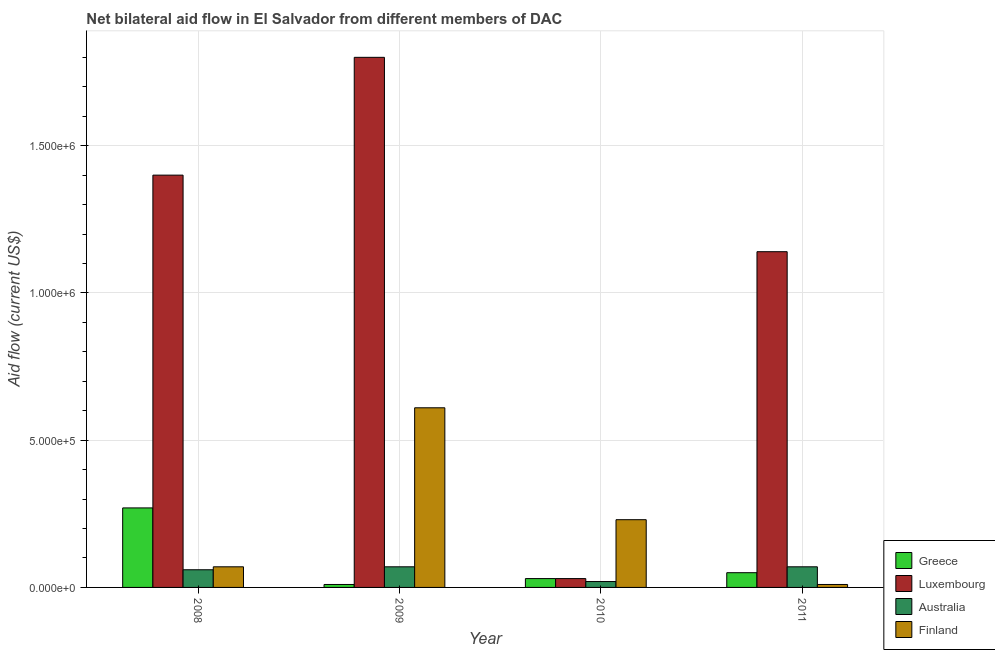How many groups of bars are there?
Your answer should be compact. 4. How many bars are there on the 4th tick from the right?
Keep it short and to the point. 4. What is the amount of aid given by australia in 2009?
Your answer should be compact. 7.00e+04. Across all years, what is the maximum amount of aid given by finland?
Keep it short and to the point. 6.10e+05. Across all years, what is the minimum amount of aid given by finland?
Make the answer very short. 10000. In which year was the amount of aid given by finland maximum?
Your answer should be compact. 2009. What is the total amount of aid given by finland in the graph?
Keep it short and to the point. 9.20e+05. What is the difference between the amount of aid given by greece in 2008 and that in 2011?
Make the answer very short. 2.20e+05. What is the difference between the amount of aid given by greece in 2010 and the amount of aid given by australia in 2011?
Give a very brief answer. -2.00e+04. What is the average amount of aid given by finland per year?
Your answer should be very brief. 2.30e+05. In how many years, is the amount of aid given by greece greater than 600000 US$?
Make the answer very short. 0. What is the ratio of the amount of aid given by luxembourg in 2008 to that in 2010?
Your answer should be compact. 46.67. Is the difference between the amount of aid given by australia in 2008 and 2010 greater than the difference between the amount of aid given by luxembourg in 2008 and 2010?
Ensure brevity in your answer.  No. What is the difference between the highest and the second highest amount of aid given by luxembourg?
Keep it short and to the point. 4.00e+05. What is the difference between the highest and the lowest amount of aid given by australia?
Offer a very short reply. 5.00e+04. Is it the case that in every year, the sum of the amount of aid given by greece and amount of aid given by luxembourg is greater than the amount of aid given by australia?
Provide a short and direct response. Yes. How many bars are there?
Offer a very short reply. 16. Are the values on the major ticks of Y-axis written in scientific E-notation?
Offer a very short reply. Yes. Does the graph contain any zero values?
Offer a terse response. No. Does the graph contain grids?
Provide a succinct answer. Yes. What is the title of the graph?
Make the answer very short. Net bilateral aid flow in El Salvador from different members of DAC. Does "Portugal" appear as one of the legend labels in the graph?
Your response must be concise. No. What is the label or title of the Y-axis?
Provide a succinct answer. Aid flow (current US$). What is the Aid flow (current US$) of Luxembourg in 2008?
Give a very brief answer. 1.40e+06. What is the Aid flow (current US$) in Australia in 2008?
Your answer should be very brief. 6.00e+04. What is the Aid flow (current US$) of Finland in 2008?
Provide a succinct answer. 7.00e+04. What is the Aid flow (current US$) in Greece in 2009?
Provide a short and direct response. 10000. What is the Aid flow (current US$) in Luxembourg in 2009?
Provide a short and direct response. 1.80e+06. What is the Aid flow (current US$) of Luxembourg in 2010?
Your answer should be compact. 3.00e+04. What is the Aid flow (current US$) of Greece in 2011?
Ensure brevity in your answer.  5.00e+04. What is the Aid flow (current US$) in Luxembourg in 2011?
Make the answer very short. 1.14e+06. What is the Aid flow (current US$) in Australia in 2011?
Your response must be concise. 7.00e+04. Across all years, what is the maximum Aid flow (current US$) of Greece?
Offer a terse response. 2.70e+05. Across all years, what is the maximum Aid flow (current US$) in Luxembourg?
Ensure brevity in your answer.  1.80e+06. Across all years, what is the minimum Aid flow (current US$) in Greece?
Your answer should be very brief. 10000. Across all years, what is the minimum Aid flow (current US$) of Australia?
Provide a short and direct response. 2.00e+04. What is the total Aid flow (current US$) of Luxembourg in the graph?
Your answer should be very brief. 4.37e+06. What is the total Aid flow (current US$) of Finland in the graph?
Provide a short and direct response. 9.20e+05. What is the difference between the Aid flow (current US$) in Luxembourg in 2008 and that in 2009?
Provide a succinct answer. -4.00e+05. What is the difference between the Aid flow (current US$) of Finland in 2008 and that in 2009?
Your response must be concise. -5.40e+05. What is the difference between the Aid flow (current US$) of Greece in 2008 and that in 2010?
Your answer should be very brief. 2.40e+05. What is the difference between the Aid flow (current US$) of Luxembourg in 2008 and that in 2010?
Keep it short and to the point. 1.37e+06. What is the difference between the Aid flow (current US$) of Luxembourg in 2008 and that in 2011?
Your answer should be compact. 2.60e+05. What is the difference between the Aid flow (current US$) of Luxembourg in 2009 and that in 2010?
Make the answer very short. 1.77e+06. What is the difference between the Aid flow (current US$) in Luxembourg in 2009 and that in 2011?
Your answer should be very brief. 6.60e+05. What is the difference between the Aid flow (current US$) in Luxembourg in 2010 and that in 2011?
Give a very brief answer. -1.11e+06. What is the difference between the Aid flow (current US$) of Australia in 2010 and that in 2011?
Provide a succinct answer. -5.00e+04. What is the difference between the Aid flow (current US$) of Finland in 2010 and that in 2011?
Offer a terse response. 2.20e+05. What is the difference between the Aid flow (current US$) in Greece in 2008 and the Aid flow (current US$) in Luxembourg in 2009?
Provide a succinct answer. -1.53e+06. What is the difference between the Aid flow (current US$) in Greece in 2008 and the Aid flow (current US$) in Australia in 2009?
Ensure brevity in your answer.  2.00e+05. What is the difference between the Aid flow (current US$) of Greece in 2008 and the Aid flow (current US$) of Finland in 2009?
Keep it short and to the point. -3.40e+05. What is the difference between the Aid flow (current US$) in Luxembourg in 2008 and the Aid flow (current US$) in Australia in 2009?
Provide a short and direct response. 1.33e+06. What is the difference between the Aid flow (current US$) of Luxembourg in 2008 and the Aid flow (current US$) of Finland in 2009?
Ensure brevity in your answer.  7.90e+05. What is the difference between the Aid flow (current US$) of Australia in 2008 and the Aid flow (current US$) of Finland in 2009?
Provide a succinct answer. -5.50e+05. What is the difference between the Aid flow (current US$) of Greece in 2008 and the Aid flow (current US$) of Luxembourg in 2010?
Keep it short and to the point. 2.40e+05. What is the difference between the Aid flow (current US$) in Greece in 2008 and the Aid flow (current US$) in Australia in 2010?
Provide a short and direct response. 2.50e+05. What is the difference between the Aid flow (current US$) of Greece in 2008 and the Aid flow (current US$) of Finland in 2010?
Provide a succinct answer. 4.00e+04. What is the difference between the Aid flow (current US$) in Luxembourg in 2008 and the Aid flow (current US$) in Australia in 2010?
Give a very brief answer. 1.38e+06. What is the difference between the Aid flow (current US$) of Luxembourg in 2008 and the Aid flow (current US$) of Finland in 2010?
Offer a very short reply. 1.17e+06. What is the difference between the Aid flow (current US$) of Australia in 2008 and the Aid flow (current US$) of Finland in 2010?
Your response must be concise. -1.70e+05. What is the difference between the Aid flow (current US$) in Greece in 2008 and the Aid flow (current US$) in Luxembourg in 2011?
Make the answer very short. -8.70e+05. What is the difference between the Aid flow (current US$) in Greece in 2008 and the Aid flow (current US$) in Australia in 2011?
Offer a terse response. 2.00e+05. What is the difference between the Aid flow (current US$) of Luxembourg in 2008 and the Aid flow (current US$) of Australia in 2011?
Your response must be concise. 1.33e+06. What is the difference between the Aid flow (current US$) of Luxembourg in 2008 and the Aid flow (current US$) of Finland in 2011?
Offer a terse response. 1.39e+06. What is the difference between the Aid flow (current US$) of Greece in 2009 and the Aid flow (current US$) of Finland in 2010?
Your answer should be very brief. -2.20e+05. What is the difference between the Aid flow (current US$) of Luxembourg in 2009 and the Aid flow (current US$) of Australia in 2010?
Provide a short and direct response. 1.78e+06. What is the difference between the Aid flow (current US$) in Luxembourg in 2009 and the Aid flow (current US$) in Finland in 2010?
Keep it short and to the point. 1.57e+06. What is the difference between the Aid flow (current US$) in Australia in 2009 and the Aid flow (current US$) in Finland in 2010?
Your answer should be compact. -1.60e+05. What is the difference between the Aid flow (current US$) of Greece in 2009 and the Aid flow (current US$) of Luxembourg in 2011?
Your answer should be very brief. -1.13e+06. What is the difference between the Aid flow (current US$) in Greece in 2009 and the Aid flow (current US$) in Australia in 2011?
Ensure brevity in your answer.  -6.00e+04. What is the difference between the Aid flow (current US$) in Luxembourg in 2009 and the Aid flow (current US$) in Australia in 2011?
Provide a succinct answer. 1.73e+06. What is the difference between the Aid flow (current US$) in Luxembourg in 2009 and the Aid flow (current US$) in Finland in 2011?
Keep it short and to the point. 1.79e+06. What is the difference between the Aid flow (current US$) in Greece in 2010 and the Aid flow (current US$) in Luxembourg in 2011?
Your response must be concise. -1.11e+06. What is the difference between the Aid flow (current US$) in Greece in 2010 and the Aid flow (current US$) in Australia in 2011?
Make the answer very short. -4.00e+04. What is the difference between the Aid flow (current US$) of Luxembourg in 2010 and the Aid flow (current US$) of Australia in 2011?
Your answer should be very brief. -4.00e+04. What is the difference between the Aid flow (current US$) of Australia in 2010 and the Aid flow (current US$) of Finland in 2011?
Your answer should be compact. 10000. What is the average Aid flow (current US$) in Luxembourg per year?
Offer a terse response. 1.09e+06. What is the average Aid flow (current US$) in Australia per year?
Your answer should be compact. 5.50e+04. What is the average Aid flow (current US$) in Finland per year?
Your answer should be compact. 2.30e+05. In the year 2008, what is the difference between the Aid flow (current US$) of Greece and Aid flow (current US$) of Luxembourg?
Offer a terse response. -1.13e+06. In the year 2008, what is the difference between the Aid flow (current US$) of Greece and Aid flow (current US$) of Australia?
Your answer should be compact. 2.10e+05. In the year 2008, what is the difference between the Aid flow (current US$) of Luxembourg and Aid flow (current US$) of Australia?
Provide a short and direct response. 1.34e+06. In the year 2008, what is the difference between the Aid flow (current US$) in Luxembourg and Aid flow (current US$) in Finland?
Ensure brevity in your answer.  1.33e+06. In the year 2009, what is the difference between the Aid flow (current US$) in Greece and Aid flow (current US$) in Luxembourg?
Provide a succinct answer. -1.79e+06. In the year 2009, what is the difference between the Aid flow (current US$) of Greece and Aid flow (current US$) of Finland?
Your answer should be very brief. -6.00e+05. In the year 2009, what is the difference between the Aid flow (current US$) in Luxembourg and Aid flow (current US$) in Australia?
Offer a very short reply. 1.73e+06. In the year 2009, what is the difference between the Aid flow (current US$) in Luxembourg and Aid flow (current US$) in Finland?
Offer a very short reply. 1.19e+06. In the year 2009, what is the difference between the Aid flow (current US$) in Australia and Aid flow (current US$) in Finland?
Provide a succinct answer. -5.40e+05. In the year 2010, what is the difference between the Aid flow (current US$) in Greece and Aid flow (current US$) in Australia?
Offer a terse response. 10000. In the year 2011, what is the difference between the Aid flow (current US$) in Greece and Aid flow (current US$) in Luxembourg?
Offer a very short reply. -1.09e+06. In the year 2011, what is the difference between the Aid flow (current US$) of Greece and Aid flow (current US$) of Australia?
Your answer should be very brief. -2.00e+04. In the year 2011, what is the difference between the Aid flow (current US$) of Greece and Aid flow (current US$) of Finland?
Keep it short and to the point. 4.00e+04. In the year 2011, what is the difference between the Aid flow (current US$) of Luxembourg and Aid flow (current US$) of Australia?
Provide a succinct answer. 1.07e+06. In the year 2011, what is the difference between the Aid flow (current US$) in Luxembourg and Aid flow (current US$) in Finland?
Offer a terse response. 1.13e+06. What is the ratio of the Aid flow (current US$) in Greece in 2008 to that in 2009?
Make the answer very short. 27. What is the ratio of the Aid flow (current US$) of Luxembourg in 2008 to that in 2009?
Your answer should be compact. 0.78. What is the ratio of the Aid flow (current US$) in Australia in 2008 to that in 2009?
Provide a short and direct response. 0.86. What is the ratio of the Aid flow (current US$) of Finland in 2008 to that in 2009?
Your answer should be very brief. 0.11. What is the ratio of the Aid flow (current US$) of Luxembourg in 2008 to that in 2010?
Make the answer very short. 46.67. What is the ratio of the Aid flow (current US$) of Australia in 2008 to that in 2010?
Provide a succinct answer. 3. What is the ratio of the Aid flow (current US$) of Finland in 2008 to that in 2010?
Offer a terse response. 0.3. What is the ratio of the Aid flow (current US$) in Greece in 2008 to that in 2011?
Offer a terse response. 5.4. What is the ratio of the Aid flow (current US$) in Luxembourg in 2008 to that in 2011?
Make the answer very short. 1.23. What is the ratio of the Aid flow (current US$) of Australia in 2008 to that in 2011?
Your response must be concise. 0.86. What is the ratio of the Aid flow (current US$) in Finland in 2008 to that in 2011?
Ensure brevity in your answer.  7. What is the ratio of the Aid flow (current US$) of Greece in 2009 to that in 2010?
Your answer should be compact. 0.33. What is the ratio of the Aid flow (current US$) of Luxembourg in 2009 to that in 2010?
Provide a succinct answer. 60. What is the ratio of the Aid flow (current US$) of Finland in 2009 to that in 2010?
Provide a succinct answer. 2.65. What is the ratio of the Aid flow (current US$) of Greece in 2009 to that in 2011?
Your response must be concise. 0.2. What is the ratio of the Aid flow (current US$) in Luxembourg in 2009 to that in 2011?
Keep it short and to the point. 1.58. What is the ratio of the Aid flow (current US$) in Greece in 2010 to that in 2011?
Provide a succinct answer. 0.6. What is the ratio of the Aid flow (current US$) in Luxembourg in 2010 to that in 2011?
Offer a very short reply. 0.03. What is the ratio of the Aid flow (current US$) of Australia in 2010 to that in 2011?
Keep it short and to the point. 0.29. What is the ratio of the Aid flow (current US$) in Finland in 2010 to that in 2011?
Provide a succinct answer. 23. What is the difference between the highest and the second highest Aid flow (current US$) in Greece?
Ensure brevity in your answer.  2.20e+05. What is the difference between the highest and the second highest Aid flow (current US$) of Luxembourg?
Your response must be concise. 4.00e+05. What is the difference between the highest and the second highest Aid flow (current US$) of Australia?
Offer a terse response. 0. What is the difference between the highest and the lowest Aid flow (current US$) in Luxembourg?
Your answer should be very brief. 1.77e+06. What is the difference between the highest and the lowest Aid flow (current US$) in Australia?
Provide a short and direct response. 5.00e+04. 